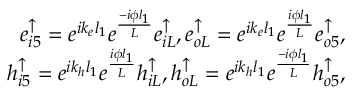Convert formula to latex. <formula><loc_0><loc_0><loc_500><loc_500>\begin{array} { r } { e _ { i 5 } ^ { \uparrow } = e ^ { i k _ { e } l _ { 1 } } e ^ { \frac { - i \phi l _ { 1 } } { L } } e _ { i L } ^ { \uparrow } , e _ { o L } ^ { \uparrow } = e ^ { i k _ { e } l _ { 1 } } e ^ { \frac { i \phi l _ { 1 } } { L } } e _ { o 5 } ^ { \uparrow } , } \\ { h _ { i 5 } ^ { \uparrow } = e ^ { i k _ { h } l _ { 1 } } e ^ { \frac { i \phi l _ { 1 } } { L } } h _ { i L } ^ { \uparrow } , h _ { o L } ^ { \uparrow } = e ^ { i k _ { h } l _ { 1 } } e ^ { \frac { - i \phi l _ { 1 } } { L } } h _ { o 5 } ^ { \uparrow } , } \end{array}</formula> 